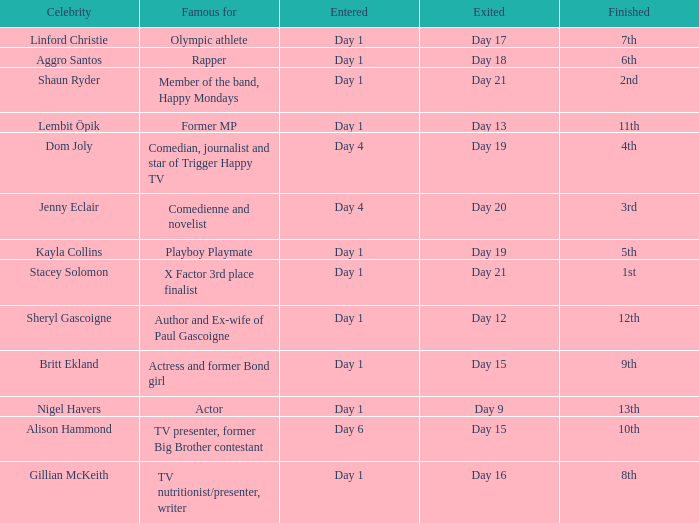What position did the celebrity finish that entered on day 1 and exited on day 19? 5th. Give me the full table as a dictionary. {'header': ['Celebrity', 'Famous for', 'Entered', 'Exited', 'Finished'], 'rows': [['Linford Christie', 'Olympic athlete', 'Day 1', 'Day 17', '7th'], ['Aggro Santos', 'Rapper', 'Day 1', 'Day 18', '6th'], ['Shaun Ryder', 'Member of the band, Happy Mondays', 'Day 1', 'Day 21', '2nd'], ['Lembit Öpik', 'Former MP', 'Day 1', 'Day 13', '11th'], ['Dom Joly', 'Comedian, journalist and star of Trigger Happy TV', 'Day 4', 'Day 19', '4th'], ['Jenny Eclair', 'Comedienne and novelist', 'Day 4', 'Day 20', '3rd'], ['Kayla Collins', 'Playboy Playmate', 'Day 1', 'Day 19', '5th'], ['Stacey Solomon', 'X Factor 3rd place finalist', 'Day 1', 'Day 21', '1st'], ['Sheryl Gascoigne', 'Author and Ex-wife of Paul Gascoigne', 'Day 1', 'Day 12', '12th'], ['Britt Ekland', 'Actress and former Bond girl', 'Day 1', 'Day 15', '9th'], ['Nigel Havers', 'Actor', 'Day 1', 'Day 9', '13th'], ['Alison Hammond', 'TV presenter, former Big Brother contestant', 'Day 6', 'Day 15', '10th'], ['Gillian McKeith', 'TV nutritionist/presenter, writer', 'Day 1', 'Day 16', '8th']]} 